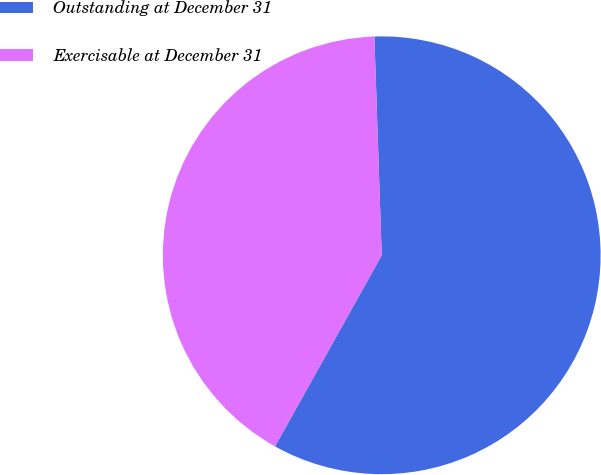<chart> <loc_0><loc_0><loc_500><loc_500><pie_chart><fcel>Outstanding at December 31<fcel>Exercisable at December 31<nl><fcel>58.64%<fcel>41.36%<nl></chart> 